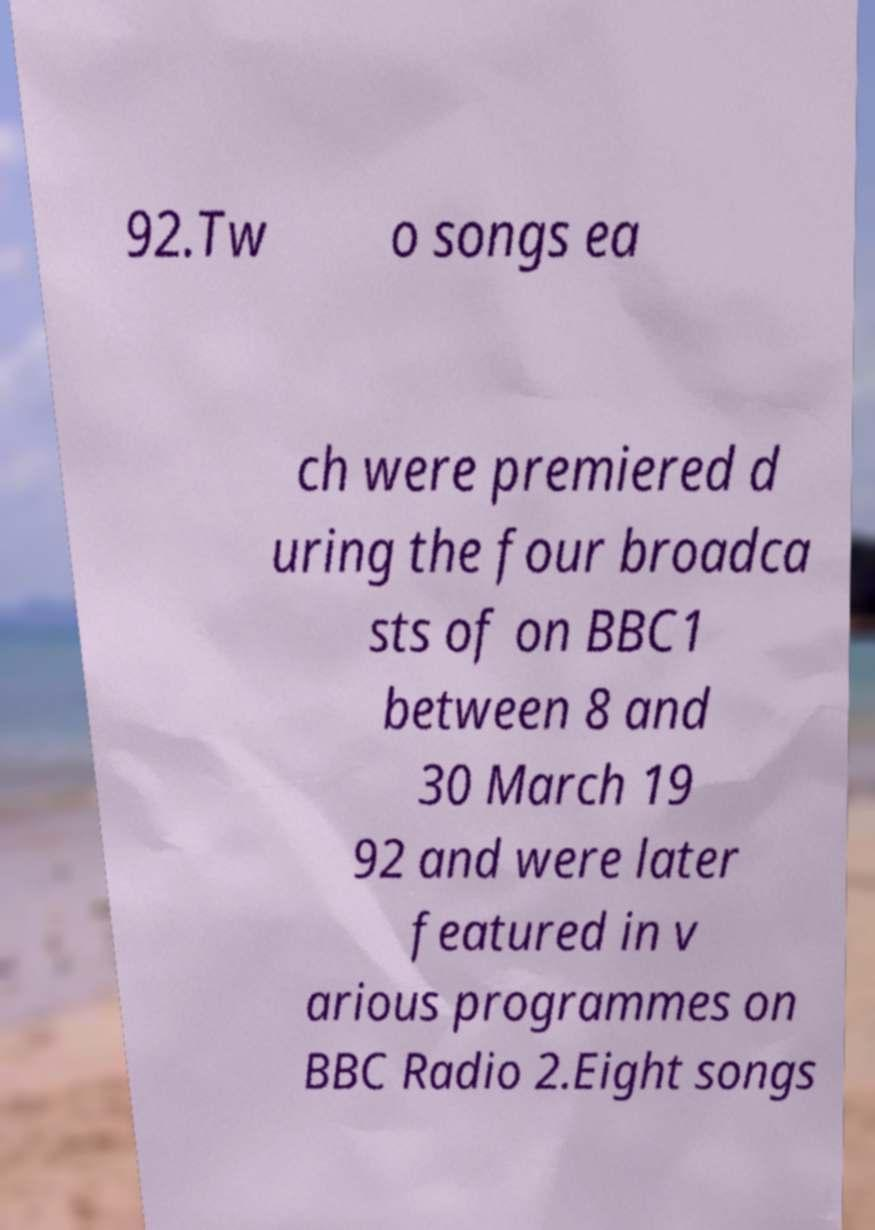There's text embedded in this image that I need extracted. Can you transcribe it verbatim? 92.Tw o songs ea ch were premiered d uring the four broadca sts of on BBC1 between 8 and 30 March 19 92 and were later featured in v arious programmes on BBC Radio 2.Eight songs 